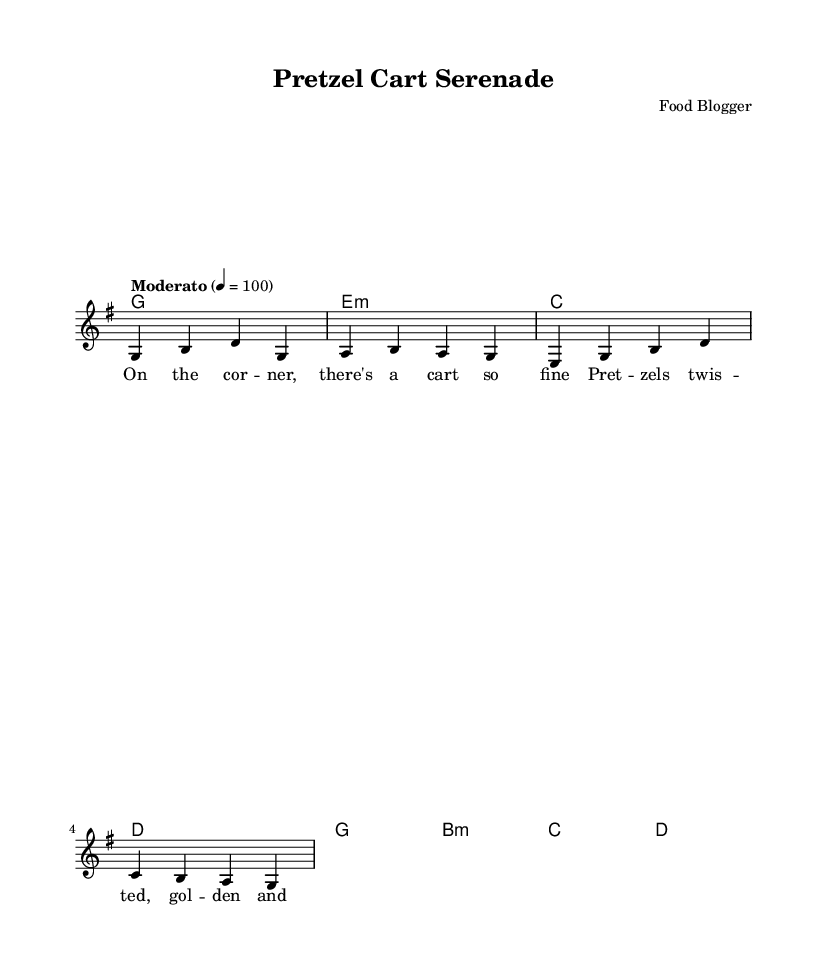What is the title of this music? The title is located at the top of the sheet music in the header section. It specifically states "Pretzel Cart Serenade."
Answer: Pretzel Cart Serenade What is the key signature of this music? The key signature can be identified right after the header, with the "g" indicating it is G major. G major has one sharp (F#).
Answer: G major What is the time signature of this music? The time signature is presented as part of the global settings, showing "4/4," which means there are four beats in each measure.
Answer: 4/4 What is the tempo marking for this music? The tempo is indicated in the global settings where it states "Moderato," followed by "4 = 100," which marks the beats per minute.
Answer: Moderato What is the first line of lyrics in the verse? The first line of lyrics can be found in the verse section, appearing underneath the melody. The first lyrics read, "On the cor - ner, there's a cart so fine."
Answer: On the cor - ner, there's a cart so fine How many measures are in the melody? To find the number of measures, we can count the individual segments separated by vertical lines (bar lines) in the melody section. There are four measures present.
Answer: 4 What is the last chord in the harmonies? The last chord is found in the harmonies section at the end of the chord progression. The last chord listed is "d," indicating the D major chord.
Answer: d 